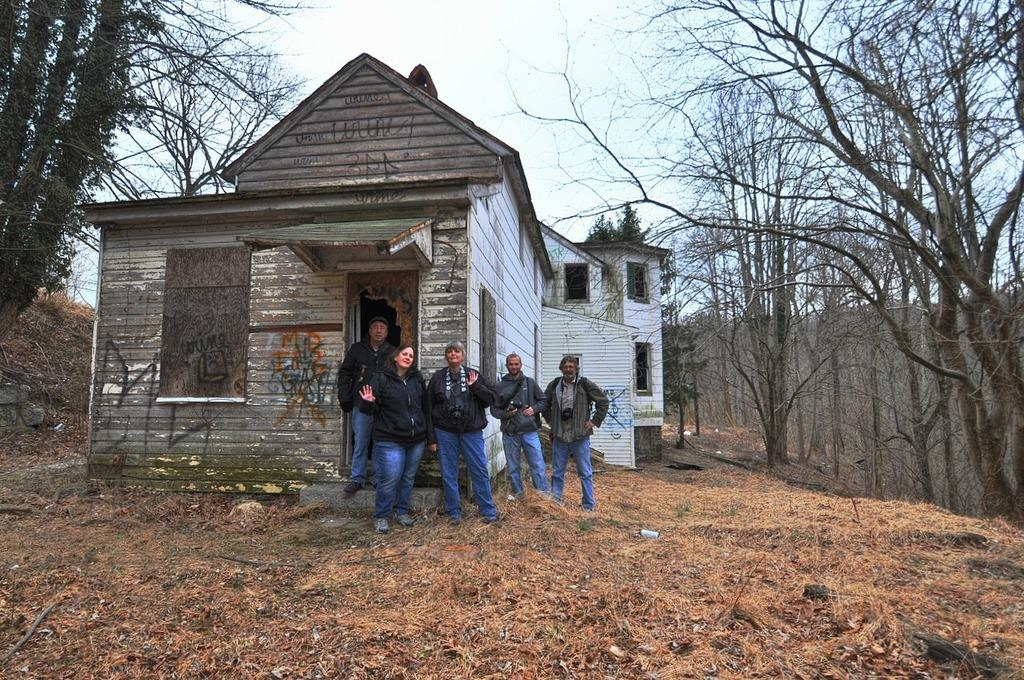What is happening in the middle of the image? There are people standing in the middle of the image. What can be seen in the background of the image? There is a house and trees in the background of the image. What is visible at the top of the image? Clouds and the sky are visible at the top of the image. How does the beggar interact with the people in the image? There is no beggar present in the image; it only shows people standing in the middle of the image. What type of roof is visible on the house in the background of the image? The image does not provide enough detail to determine the type of roof on the house in the background. 